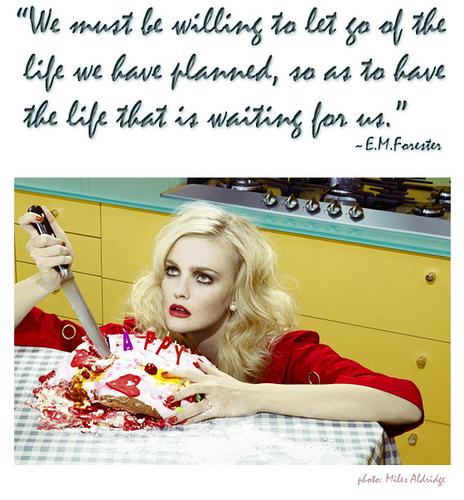What is the girl going to eat?
Be succinct. Cake. Is someone a bit of a drama queen?
Write a very short answer. Yes. Did she just murder a cake?
Be succinct. Yes. 